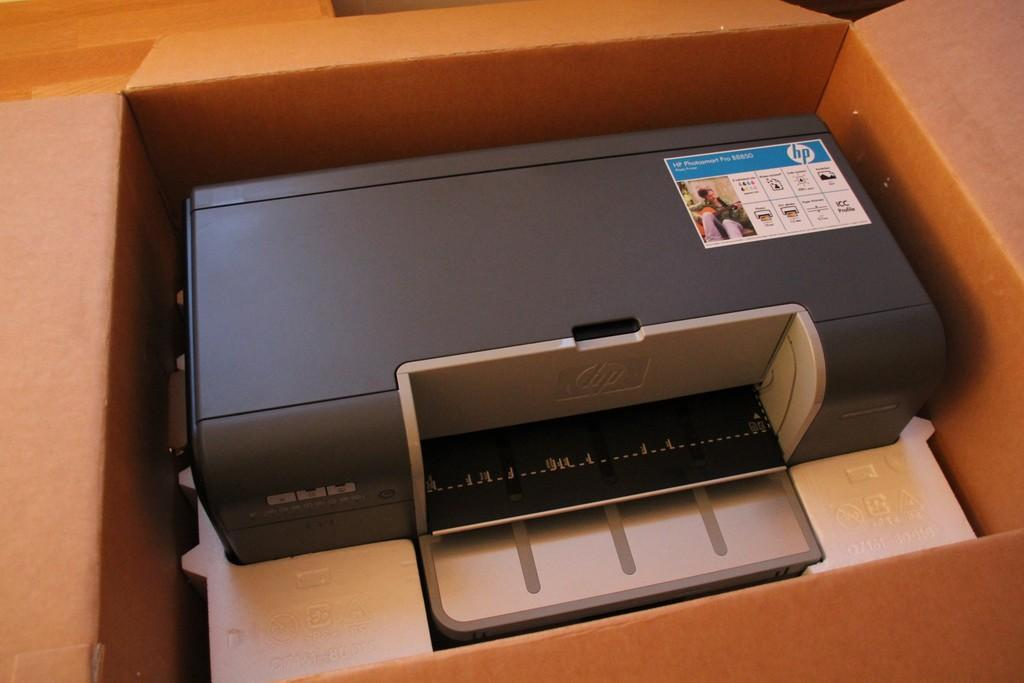Provide a one-sentence caption for the provided image. The HP photo printer is compact and high quality. 